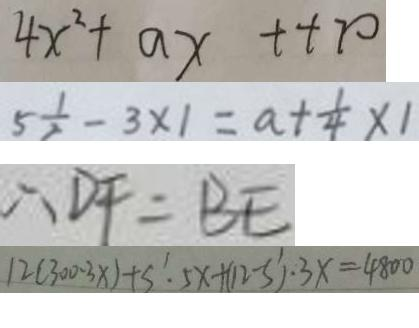<formula> <loc_0><loc_0><loc_500><loc_500>4 x ^ { 2 } + a x + + 7 0 
 5 \frac { 1 } { 2 } - 3 \times 1 = a + \frac { 1 } { 4 } \times 1 
 \therefore D F = B E 
 1 2 ( 3 0 0 - 3 x ) + s ^ { \prime } . 5 x + ( 1 2 - s ^ { \prime } ) \cdot 3 x = 4 8 0 0</formula> 